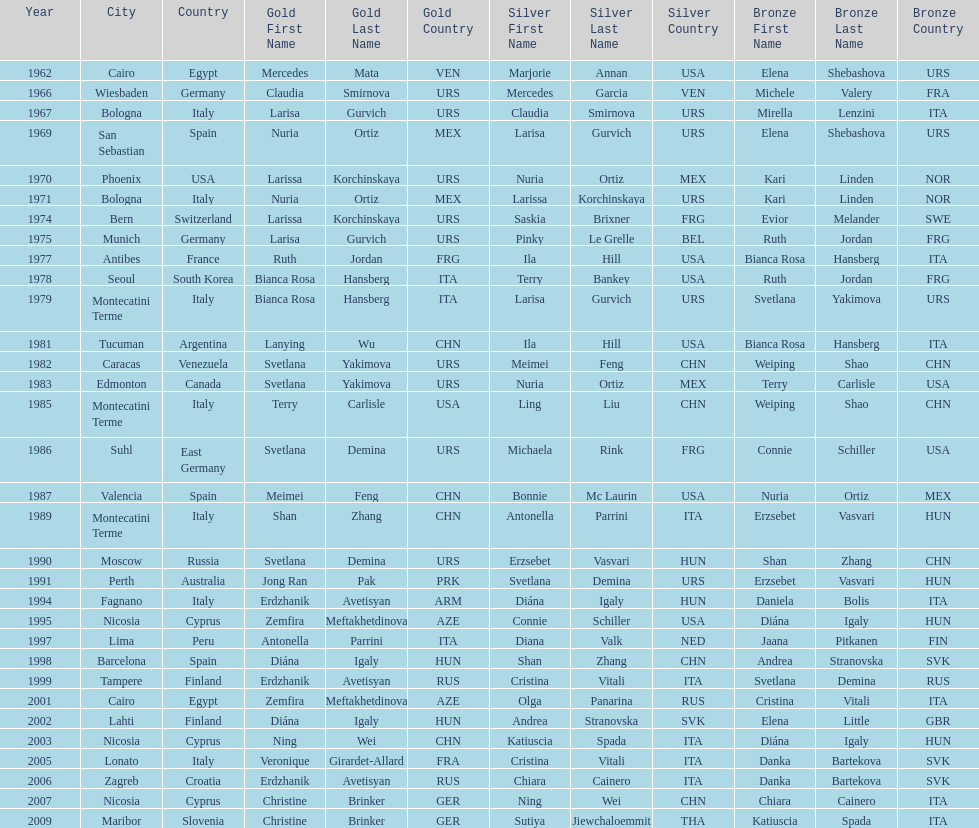Which country has the most bronze medals? Italy. 